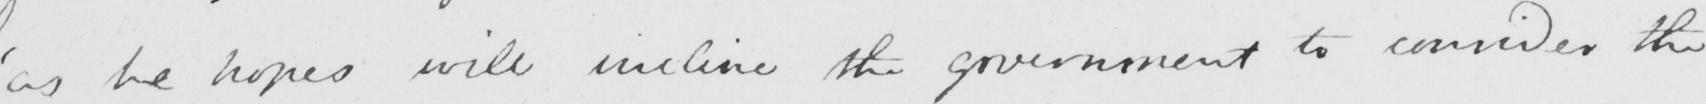What does this handwritten line say? ' as he hopes will incline the government to consider the 